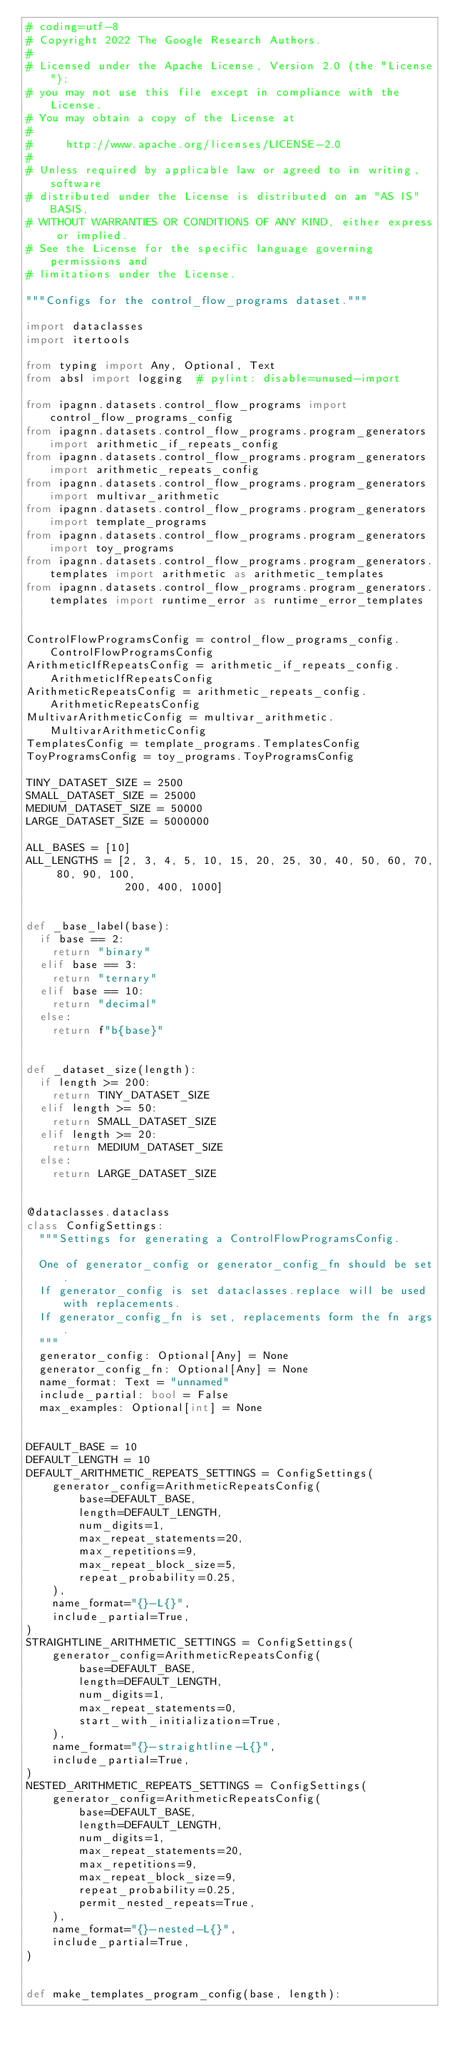<code> <loc_0><loc_0><loc_500><loc_500><_Python_># coding=utf-8
# Copyright 2022 The Google Research Authors.
#
# Licensed under the Apache License, Version 2.0 (the "License");
# you may not use this file except in compliance with the License.
# You may obtain a copy of the License at
#
#     http://www.apache.org/licenses/LICENSE-2.0
#
# Unless required by applicable law or agreed to in writing, software
# distributed under the License is distributed on an "AS IS" BASIS,
# WITHOUT WARRANTIES OR CONDITIONS OF ANY KIND, either express or implied.
# See the License for the specific language governing permissions and
# limitations under the License.

"""Configs for the control_flow_programs dataset."""

import dataclasses
import itertools

from typing import Any, Optional, Text
from absl import logging  # pylint: disable=unused-import

from ipagnn.datasets.control_flow_programs import control_flow_programs_config
from ipagnn.datasets.control_flow_programs.program_generators import arithmetic_if_repeats_config
from ipagnn.datasets.control_flow_programs.program_generators import arithmetic_repeats_config
from ipagnn.datasets.control_flow_programs.program_generators import multivar_arithmetic
from ipagnn.datasets.control_flow_programs.program_generators import template_programs
from ipagnn.datasets.control_flow_programs.program_generators import toy_programs
from ipagnn.datasets.control_flow_programs.program_generators.templates import arithmetic as arithmetic_templates
from ipagnn.datasets.control_flow_programs.program_generators.templates import runtime_error as runtime_error_templates


ControlFlowProgramsConfig = control_flow_programs_config.ControlFlowProgramsConfig
ArithmeticIfRepeatsConfig = arithmetic_if_repeats_config.ArithmeticIfRepeatsConfig
ArithmeticRepeatsConfig = arithmetic_repeats_config.ArithmeticRepeatsConfig
MultivarArithmeticConfig = multivar_arithmetic.MultivarArithmeticConfig
TemplatesConfig = template_programs.TemplatesConfig
ToyProgramsConfig = toy_programs.ToyProgramsConfig

TINY_DATASET_SIZE = 2500
SMALL_DATASET_SIZE = 25000
MEDIUM_DATASET_SIZE = 50000
LARGE_DATASET_SIZE = 5000000

ALL_BASES = [10]
ALL_LENGTHS = [2, 3, 4, 5, 10, 15, 20, 25, 30, 40, 50, 60, 70, 80, 90, 100,
               200, 400, 1000]


def _base_label(base):
  if base == 2:
    return "binary"
  elif base == 3:
    return "ternary"
  elif base == 10:
    return "decimal"
  else:
    return f"b{base}"


def _dataset_size(length):
  if length >= 200:
    return TINY_DATASET_SIZE
  elif length >= 50:
    return SMALL_DATASET_SIZE
  elif length >= 20:
    return MEDIUM_DATASET_SIZE
  else:
    return LARGE_DATASET_SIZE


@dataclasses.dataclass
class ConfigSettings:
  """Settings for generating a ControlFlowProgramsConfig.

  One of generator_config or generator_config_fn should be set.
  If generator_config is set dataclasses.replace will be used with replacements.
  If generator_config_fn is set, replacements form the fn args.
  """
  generator_config: Optional[Any] = None
  generator_config_fn: Optional[Any] = None
  name_format: Text = "unnamed"
  include_partial: bool = False
  max_examples: Optional[int] = None


DEFAULT_BASE = 10
DEFAULT_LENGTH = 10
DEFAULT_ARITHMETIC_REPEATS_SETTINGS = ConfigSettings(
    generator_config=ArithmeticRepeatsConfig(
        base=DEFAULT_BASE,
        length=DEFAULT_LENGTH,
        num_digits=1,
        max_repeat_statements=20,
        max_repetitions=9,
        max_repeat_block_size=5,
        repeat_probability=0.25,
    ),
    name_format="{}-L{}",
    include_partial=True,
)
STRAIGHTLINE_ARITHMETIC_SETTINGS = ConfigSettings(
    generator_config=ArithmeticRepeatsConfig(
        base=DEFAULT_BASE,
        length=DEFAULT_LENGTH,
        num_digits=1,
        max_repeat_statements=0,
        start_with_initialization=True,
    ),
    name_format="{}-straightline-L{}",
    include_partial=True,
)
NESTED_ARITHMETIC_REPEATS_SETTINGS = ConfigSettings(
    generator_config=ArithmeticRepeatsConfig(
        base=DEFAULT_BASE,
        length=DEFAULT_LENGTH,
        num_digits=1,
        max_repeat_statements=20,
        max_repetitions=9,
        max_repeat_block_size=9,
        repeat_probability=0.25,
        permit_nested_repeats=True,
    ),
    name_format="{}-nested-L{}",
    include_partial=True,
)


def make_templates_program_config(base, length):</code> 